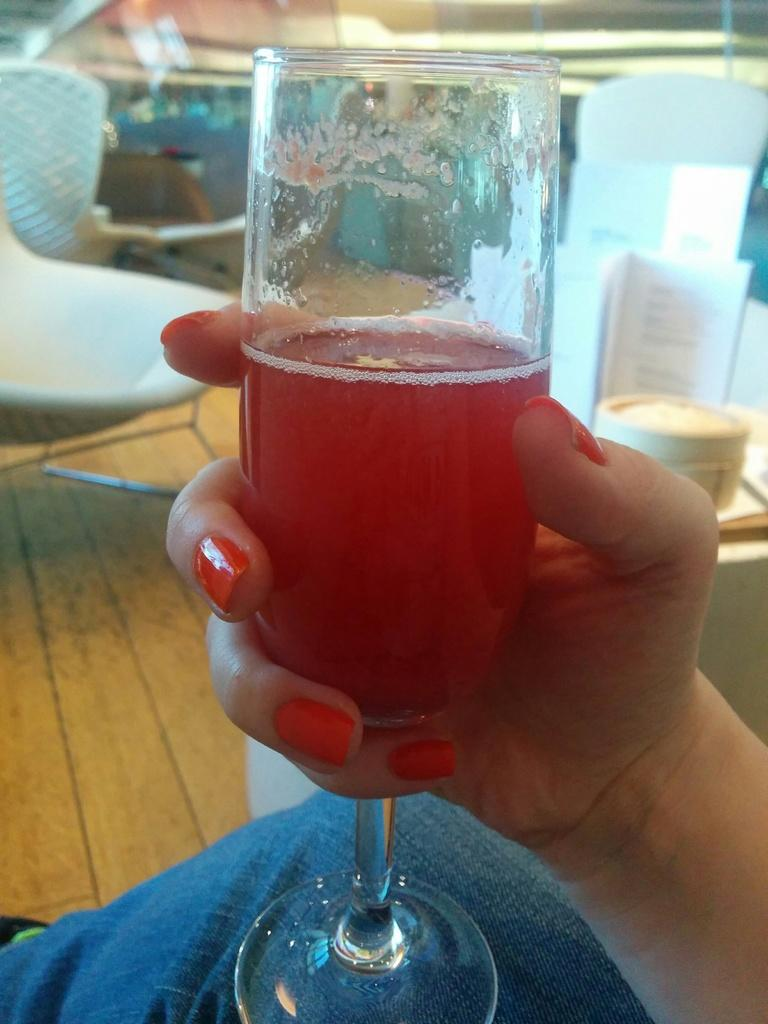What is the person in the image doing? The person is sitting in the image. What is the person holding in the image? The person is holding a glass in the image. What other objects can be seen on the table? There is a cup and a board on the table in the image. What type of furniture is visible at the back of the image? There are chairs at the back of the image. What can be seen at the top of the image? There is a light visible at the top of the image. What type of island can be seen in the background of the image? There is no island present in the image; it is an indoor setting with a person sitting at a table. 